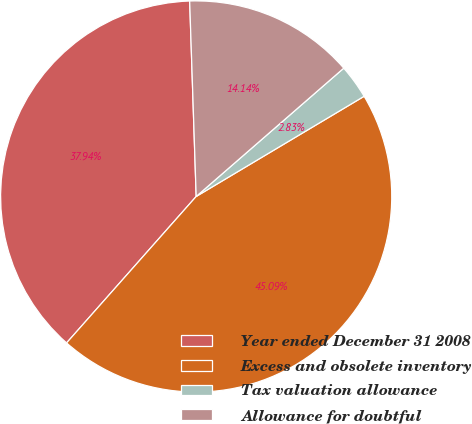Convert chart to OTSL. <chart><loc_0><loc_0><loc_500><loc_500><pie_chart><fcel>Year ended December 31 2008<fcel>Excess and obsolete inventory<fcel>Tax valuation allowance<fcel>Allowance for doubtful<nl><fcel>37.94%<fcel>45.09%<fcel>2.83%<fcel>14.14%<nl></chart> 